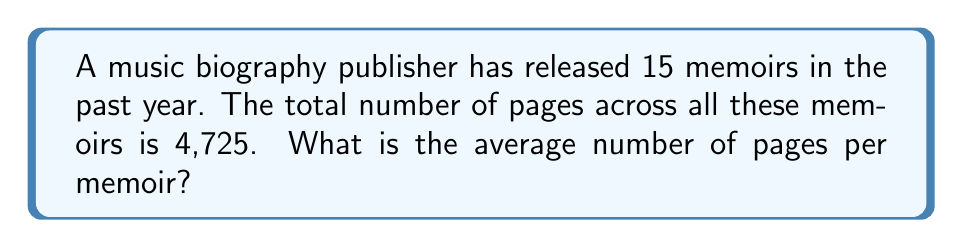What is the answer to this math problem? To find the average number of pages per memoir, we need to divide the total number of pages by the number of memoirs.

Let's define our variables:
$n$ = number of memoirs = 15
$p$ = total number of pages = 4,725

The formula for calculating the average is:

$$\text{Average} = \frac{\text{Sum of all values}}{\text{Number of values}}$$

In this case:

$$\text{Average pages per memoir} = \frac{p}{n} = \frac{4,725}{15}$$

Now, let's perform the division:

$$\frac{4,725}{15} = 315$$

Therefore, the average number of pages per memoir is 315.
Answer: 315 pages 